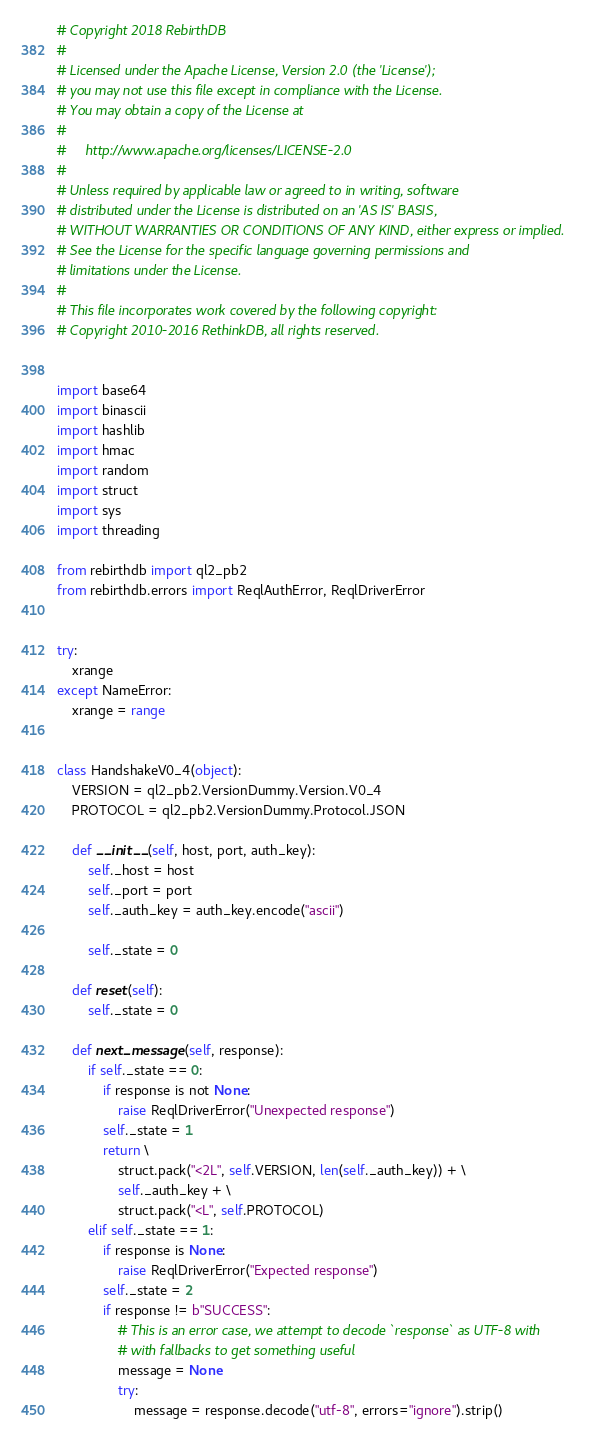<code> <loc_0><loc_0><loc_500><loc_500><_Python_># Copyright 2018 RebirthDB
#
# Licensed under the Apache License, Version 2.0 (the 'License');
# you may not use this file except in compliance with the License.
# You may obtain a copy of the License at
#
#     http://www.apache.org/licenses/LICENSE-2.0
#
# Unless required by applicable law or agreed to in writing, software
# distributed under the License is distributed on an 'AS IS' BASIS,
# WITHOUT WARRANTIES OR CONDITIONS OF ANY KIND, either express or implied.
# See the License for the specific language governing permissions and
# limitations under the License.
#
# This file incorporates work covered by the following copyright:
# Copyright 2010-2016 RethinkDB, all rights reserved.


import base64
import binascii
import hashlib
import hmac
import random
import struct
import sys
import threading

from rebirthdb import ql2_pb2
from rebirthdb.errors import ReqlAuthError, ReqlDriverError


try:
    xrange
except NameError:
    xrange = range


class HandshakeV0_4(object):
    VERSION = ql2_pb2.VersionDummy.Version.V0_4
    PROTOCOL = ql2_pb2.VersionDummy.Protocol.JSON

    def __init__(self, host, port, auth_key):
        self._host = host
        self._port = port
        self._auth_key = auth_key.encode("ascii")

        self._state = 0

    def reset(self):
        self._state = 0

    def next_message(self, response):
        if self._state == 0:
            if response is not None:
                raise ReqlDriverError("Unexpected response")
            self._state = 1
            return \
                struct.pack("<2L", self.VERSION, len(self._auth_key)) + \
                self._auth_key + \
                struct.pack("<L", self.PROTOCOL)
        elif self._state == 1:
            if response is None:
                raise ReqlDriverError("Expected response")
            self._state = 2
            if response != b"SUCCESS":
                # This is an error case, we attempt to decode `response` as UTF-8 with
                # with fallbacks to get something useful
                message = None
                try:
                    message = response.decode("utf-8", errors="ignore").strip()</code> 